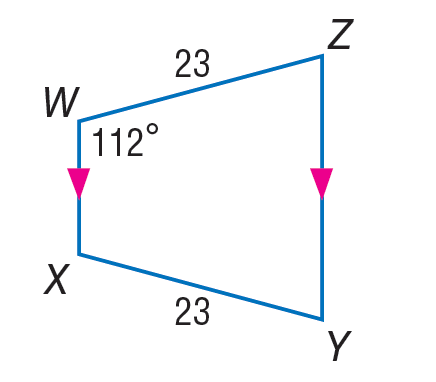Answer the mathemtical geometry problem and directly provide the correct option letter.
Question: Find m \angle Z in the trapezoid.
Choices: A: 23 B: 46 C: 68 D: 112 C 